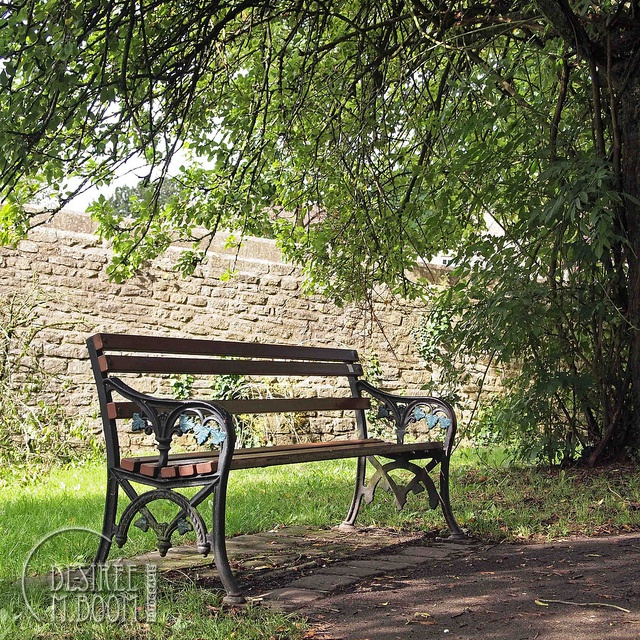Describe the objects in this image and their specific colors. I can see a bench in white, black, gray, beige, and khaki tones in this image. 